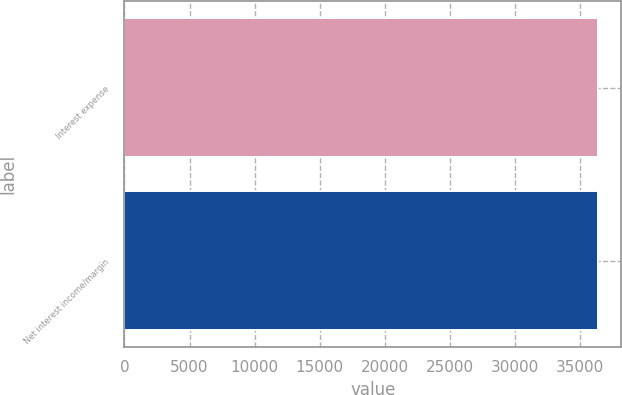<chart> <loc_0><loc_0><loc_500><loc_500><bar_chart><fcel>Interest expense<fcel>Net interest income/margin<nl><fcel>36368<fcel>36368.1<nl></chart> 